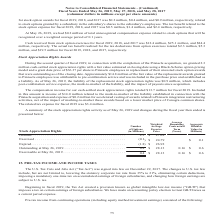According to Conagra Brands's financial document, How much was the total compensation income for cash-settled stock appreciation rights during fiscal 2019? According to the financial document, $13.7 million. The relevant text states: "our cash-settled stock appreciation rights totaled $13.7 million for fiscal 2019. Included..." Also, What is included in the liability of the replacement stock appreciation rights? post-combination service expense, the mark-to-market of the liability, and the impact of payouts since acquisition. The document states: "reciation rights was $0.9 million, which includes post-combination service expense, the mark-to-market of the liability, and the impact of payouts sin..." Also, What was the total intrinsic value of exercisable stock appreciation rights during fiscal 2019? According to the financial document, $0.6 (in millions). The relevant text states: "Outstanding at May 26, 2019. . 0.4 $ 28.13 0.16 $ 0.6..." Also, can you calculate: What is the total price of exercised and expired stocks? Based on the calculation: (0.1*24.79)+(1.8*26.92) , the result is 50.94 (in millions). This is based on the information: "Expired. . (1.8) $ 26.92 Exercised . (0.1) $ 24.79 $ 0.1 recognized over a weighted average period of 0.1 years. Expired. . (1.8) $ 26.92..." The key data points involved are: 0.1, 1.8, 24.79. Also, can you calculate: What is the ratio of granted stocks to exercisable stocks? Based on the calculation: 2.3/0.4 , the result is 5.75. This is based on the information: "or fiscal 2019, 2018, and 2017 was $0.2 million, $0.4 million, and $0.9 million, respectively, related to stock options granted by a subsidiary in the su the tax deductions from option exercises total..." The key data points involved are: 0.4, 2.3. Also, can you calculate: What is the proportion of exercised and expired stocks over granted stocks? To answer this question, I need to perform calculations using the financial data. The calculation is: (0.1+1.8)/2.3 , which equals 0.83. This is based on the information: "Expired. . (1.8) $ 26.92 recognized over a weighted average period of 0.1 years. the tax deductions from option exercises totaled $2.3 million, $5.3 million, and $19.5 million for fiscal 2019, 2018, a..." The key data points involved are: 0.1, 1.8, 2.3. 